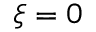<formula> <loc_0><loc_0><loc_500><loc_500>\xi = 0</formula> 